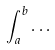Convert formula to latex. <formula><loc_0><loc_0><loc_500><loc_500>\int _ { a } ^ { b } \dots</formula> 